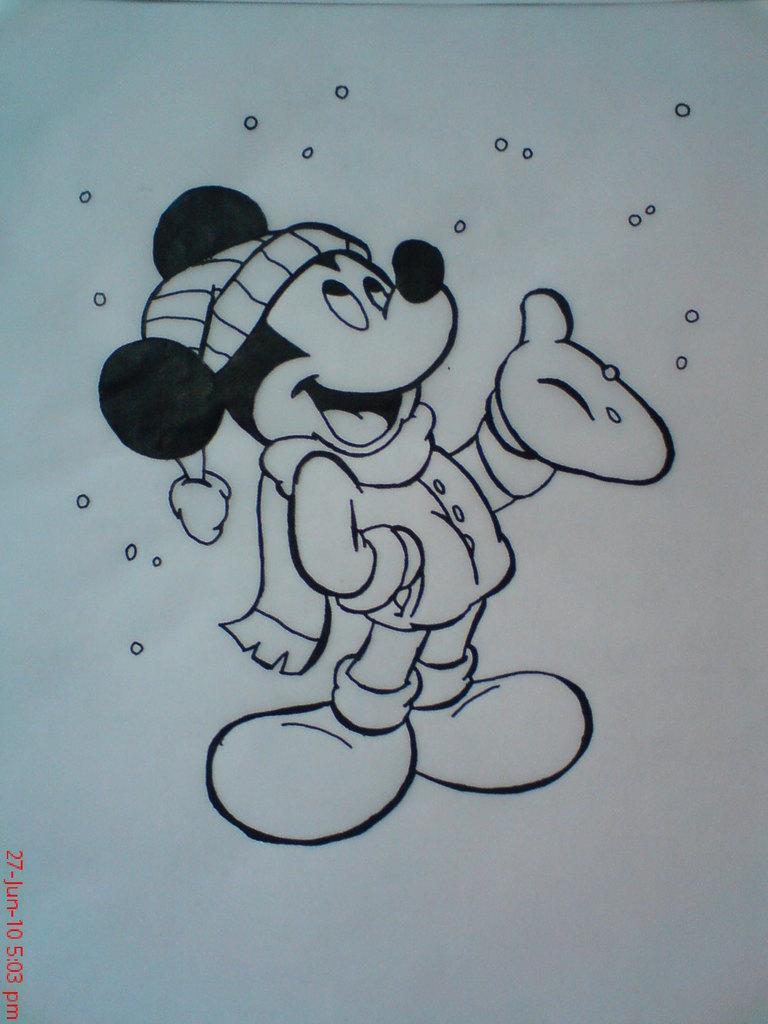Can you describe this image briefly? This is a sketch. In this picture we can see a Mickey mouse. 